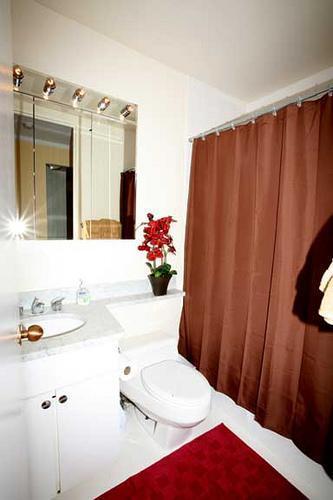How many of the kites are shaped like an iguana?
Give a very brief answer. 0. 